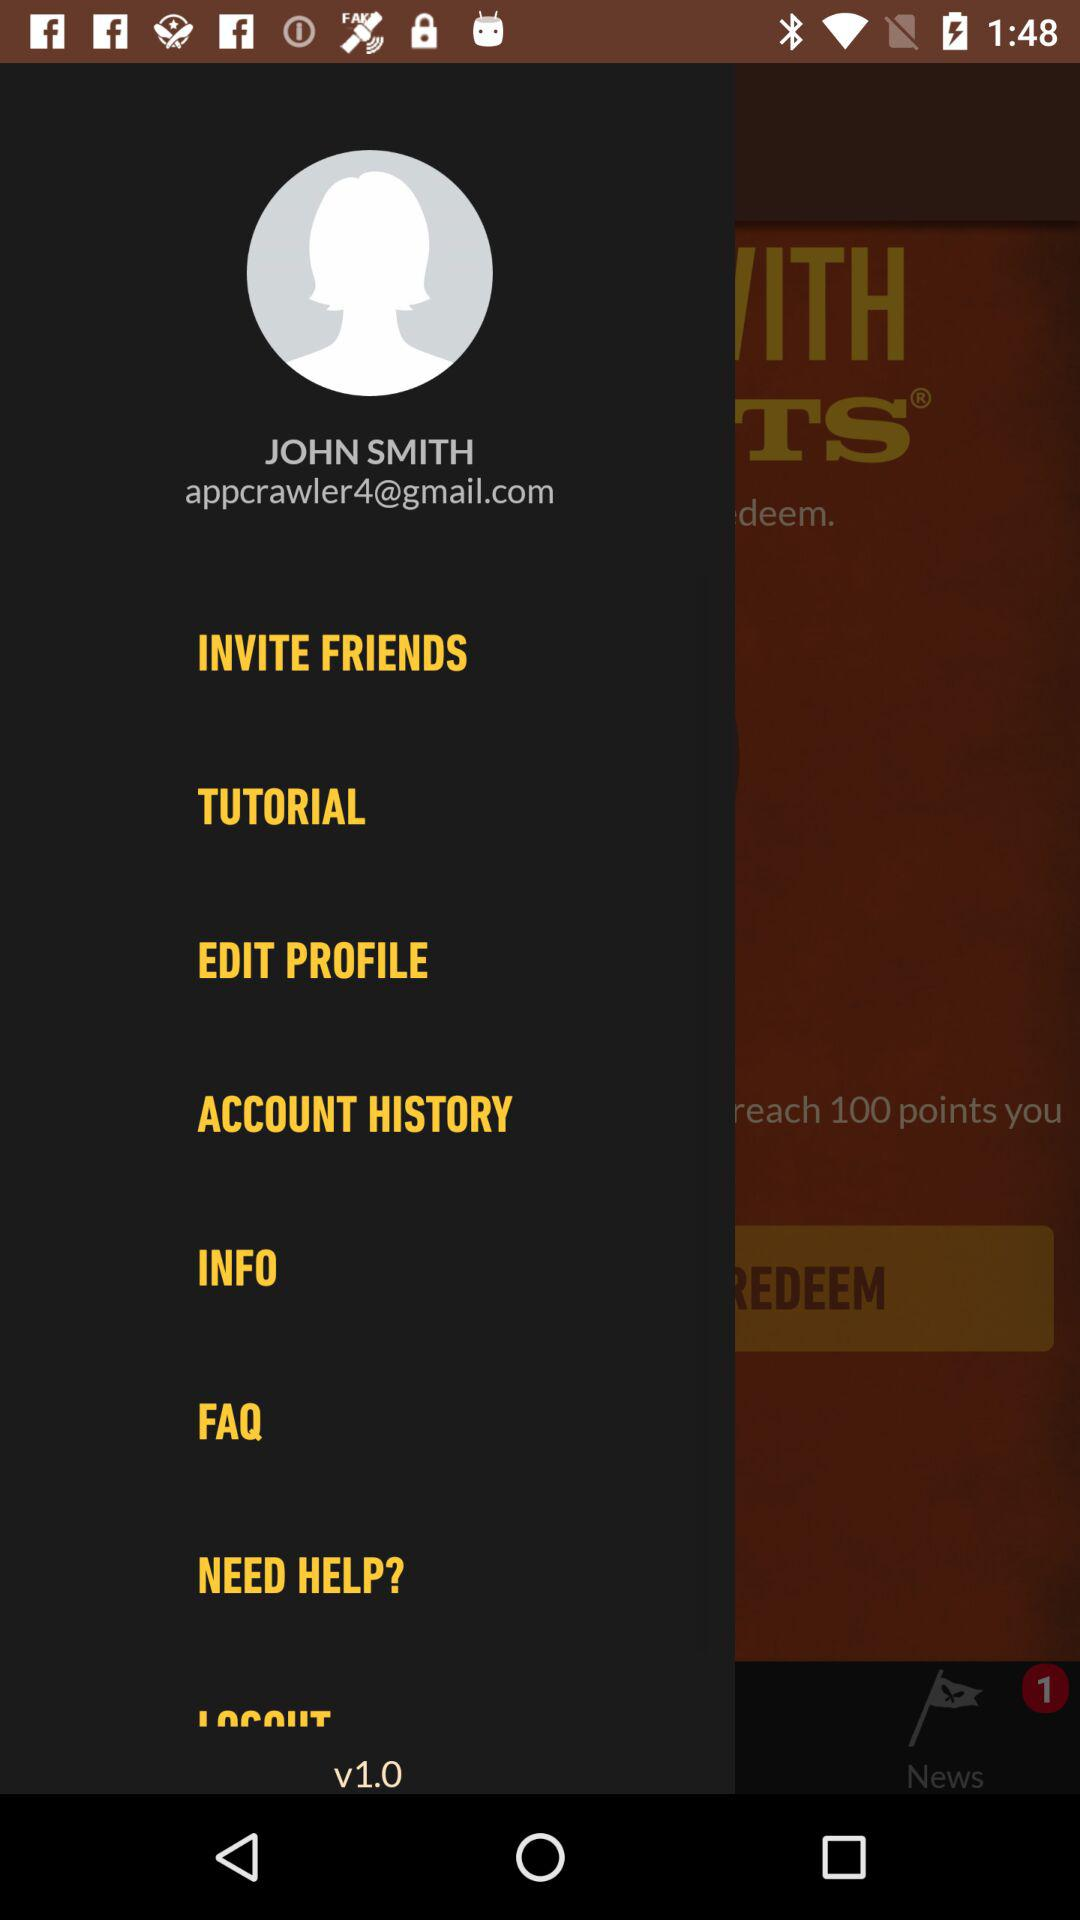What is the email address of the user? The email address is appcrawler4@gmail.com. 